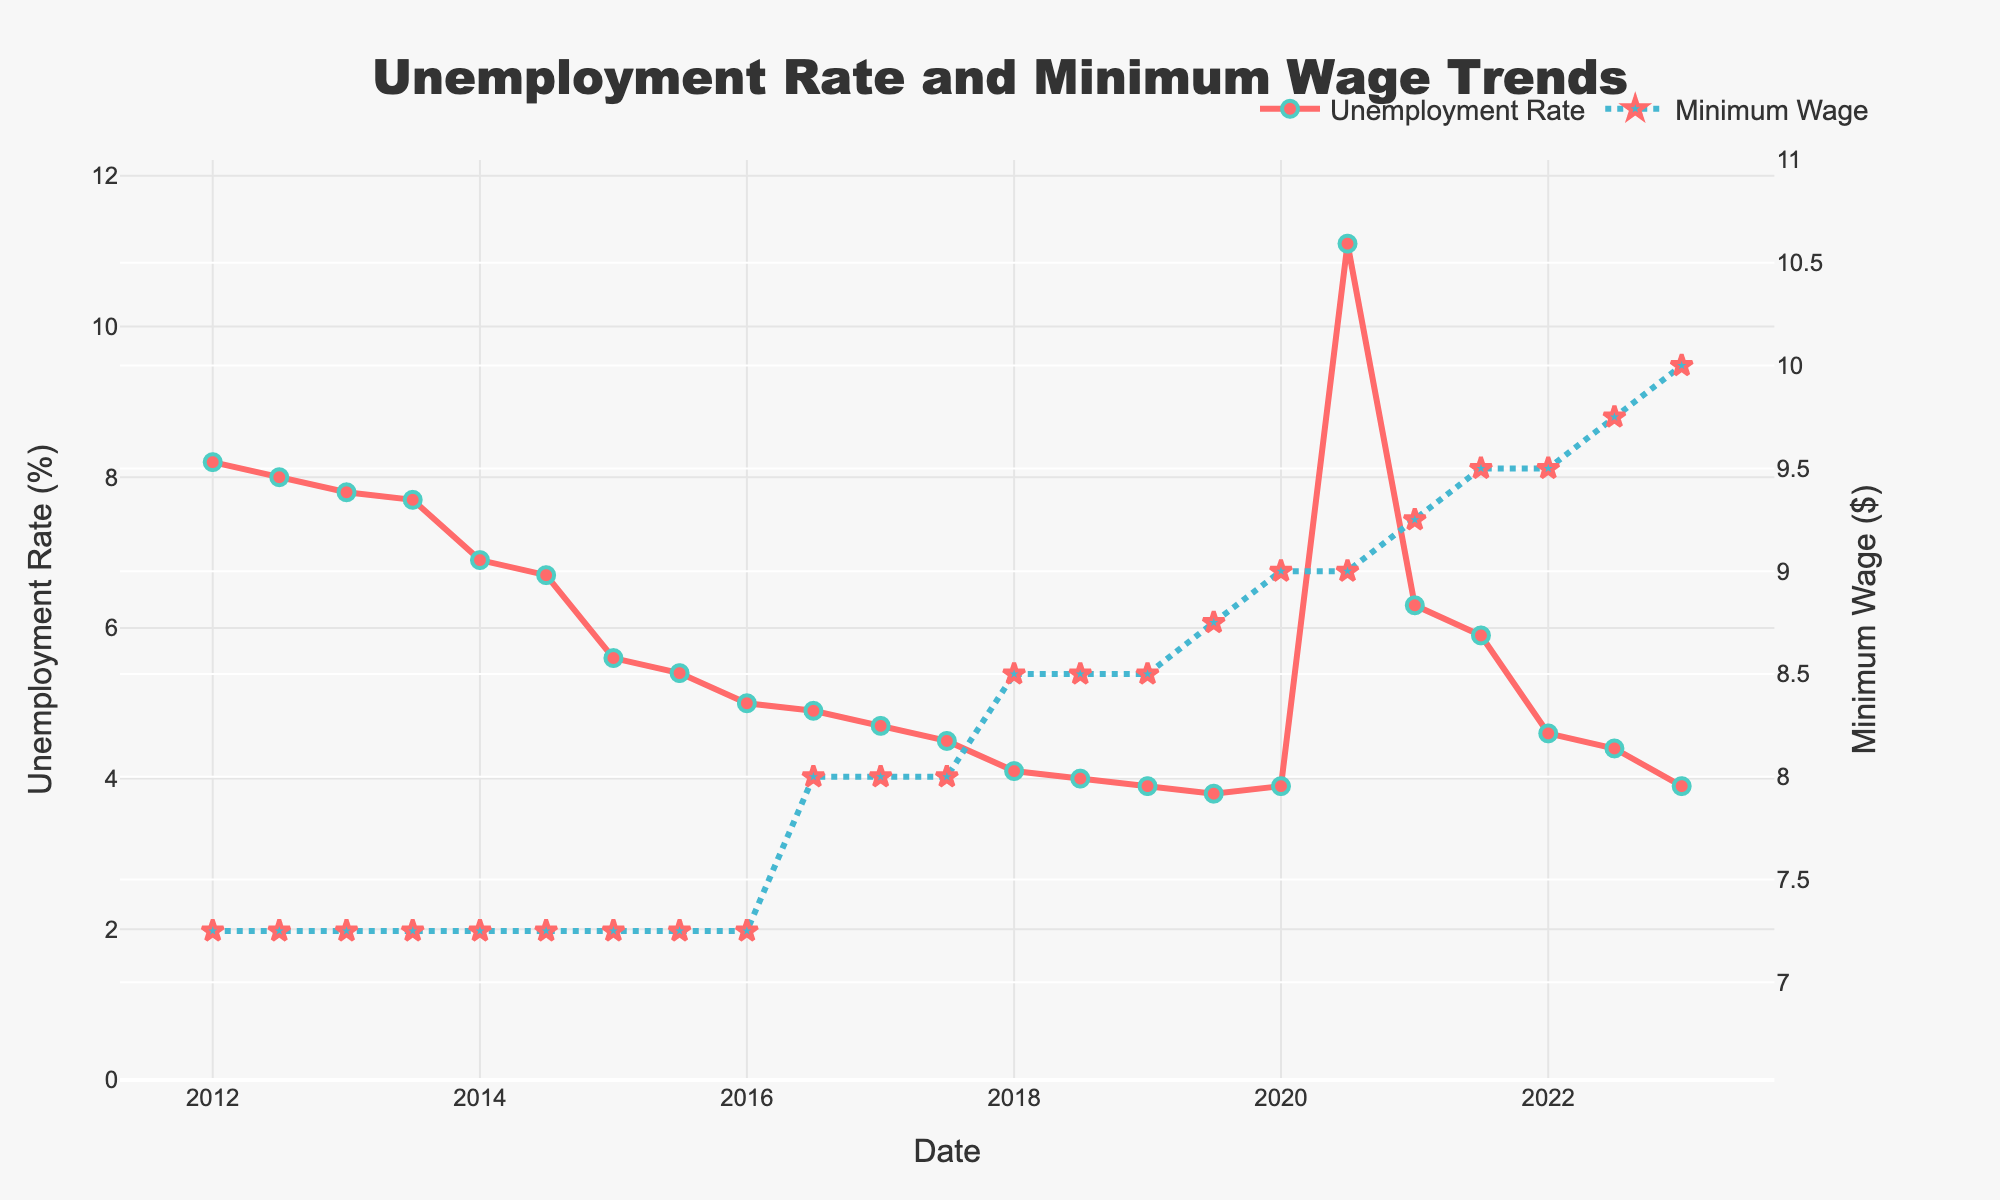How many unique data points are displayed in the figure? Count the number of data points along the x-axis. There are dates shown for each data point, starting from January 2012 to January 2023.
Answer: 22 What is the color of the line representing the Unemployment Rate? Observe the color used for the Unemployment Rate line. It is a solid red line with markers.
Answer: Red Between which years did the Minimum Wage first increase? Look for changes in the Minimum Wage line, which initially remains flat. The first increase happens between 2015 and 2016.
Answer: 2015 and 2016 What is the general trend of the Unemployment Rate from 2012 to 2023? Observe the overall direction of the Unemployment Rate line. It decreases from around 8.2% in 2012 to around 3.9% in 2023, with a peak in mid-2020.
Answer: Decreasing Which year experienced the highest Unemployment Rate and what was its value? Identify the highest point in the Unemployment Rate line. The peak occurs in mid-2020 with a value of 11.1%.
Answer: 2020, 11.1% How did the Unemployment Rate change immediately following the first Minimum Wage increase in 2016? Observe the Unemployment Rate before and after the Minimum Wage increase from $7.25 to $8.00 in 2016. It was around 5.0% in early 2016 and decreased to around 4.7% by early 2017.
Answer: Decreased By how much did the Minimum Wage change from July 2016 to January 2023? Calculate the difference between the Minimum Wage in July 2016 and January 2023. It increased from $8.00 to $10.00, which is an increase of $2.00.
Answer: $2.00 What was the Unemployment Rate in January 2021? Check the Unemployment Rate value for January 2021 on the plot. It was 6.3%.
Answer: 6.3% How did the Unemployment Rate trend from mid-2020 to mid-2021? Observe the Unemployment Rate line between mid-2020 and mid-2021. It dropped from 11.1% to 5.9%.
Answer: Decreased Which periods saw simultaneous increases in both Unemployment Rate and Minimum Wage? Look for periods where both lines are increasing. This is observed in the first half of 2020 when both the Unemployment Rate (from 3.8% to 11.1%) and Minimum Wage (from $8.75 to $9.00) increased.
Answer: First half of 2020 